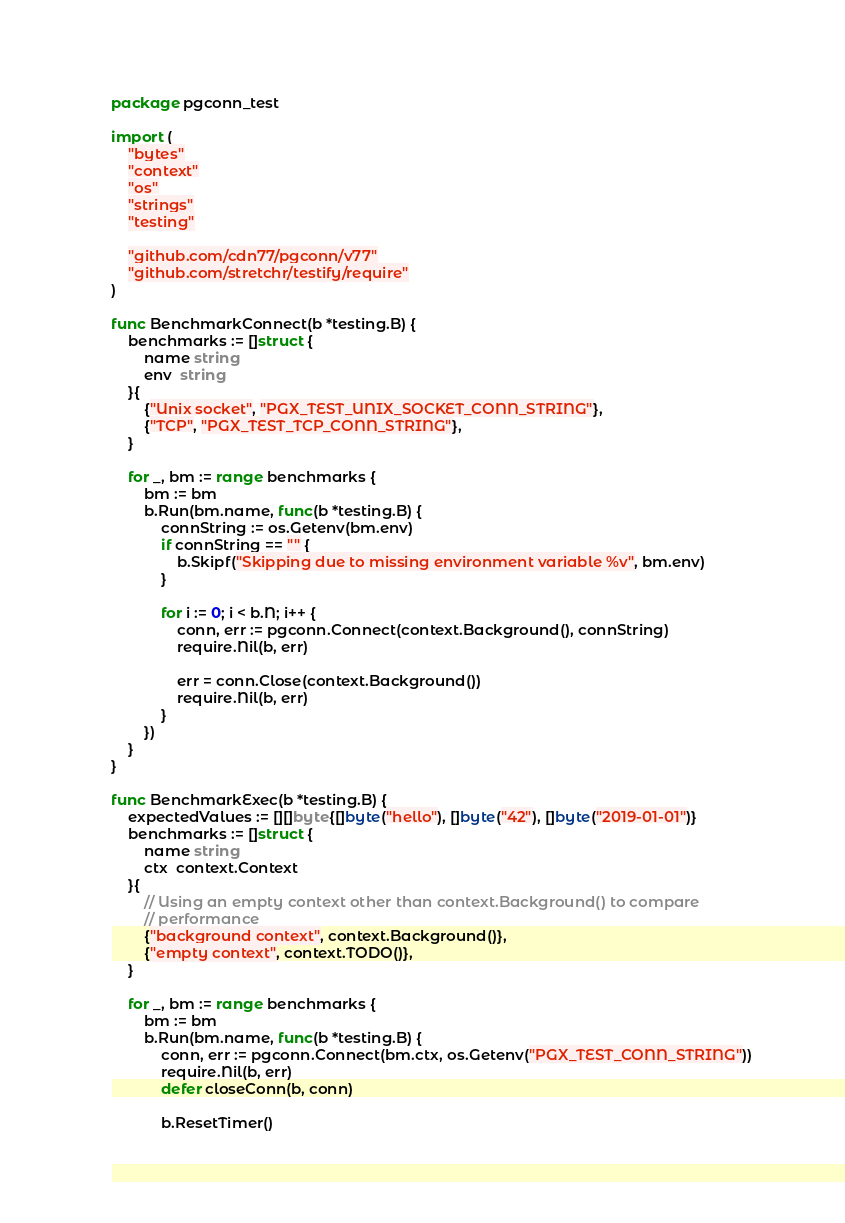Convert code to text. <code><loc_0><loc_0><loc_500><loc_500><_Go_>package pgconn_test

import (
	"bytes"
	"context"
	"os"
	"strings"
	"testing"

	"github.com/cdn77/pgconn/v77"
	"github.com/stretchr/testify/require"
)

func BenchmarkConnect(b *testing.B) {
	benchmarks := []struct {
		name string
		env  string
	}{
		{"Unix socket", "PGX_TEST_UNIX_SOCKET_CONN_STRING"},
		{"TCP", "PGX_TEST_TCP_CONN_STRING"},
	}

	for _, bm := range benchmarks {
		bm := bm
		b.Run(bm.name, func(b *testing.B) {
			connString := os.Getenv(bm.env)
			if connString == "" {
				b.Skipf("Skipping due to missing environment variable %v", bm.env)
			}

			for i := 0; i < b.N; i++ {
				conn, err := pgconn.Connect(context.Background(), connString)
				require.Nil(b, err)

				err = conn.Close(context.Background())
				require.Nil(b, err)
			}
		})
	}
}

func BenchmarkExec(b *testing.B) {
	expectedValues := [][]byte{[]byte("hello"), []byte("42"), []byte("2019-01-01")}
	benchmarks := []struct {
		name string
		ctx  context.Context
	}{
		// Using an empty context other than context.Background() to compare
		// performance
		{"background context", context.Background()},
		{"empty context", context.TODO()},
	}

	for _, bm := range benchmarks {
		bm := bm
		b.Run(bm.name, func(b *testing.B) {
			conn, err := pgconn.Connect(bm.ctx, os.Getenv("PGX_TEST_CONN_STRING"))
			require.Nil(b, err)
			defer closeConn(b, conn)

			b.ResetTimer()
</code> 